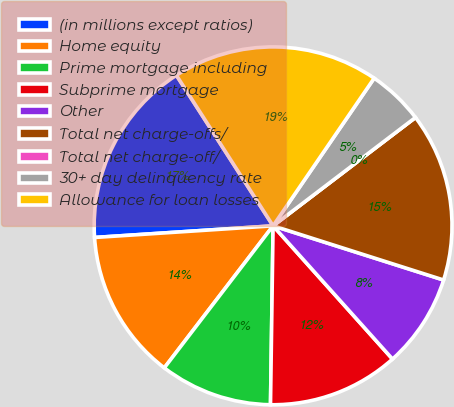<chart> <loc_0><loc_0><loc_500><loc_500><pie_chart><fcel>(in millions except ratios)<fcel>Home equity<fcel>Prime mortgage including<fcel>Subprime mortgage<fcel>Other<fcel>Total net charge-offs/<fcel>Total net charge-off/<fcel>30+ day delinquency rate<fcel>Allowance for loan losses<nl><fcel>16.95%<fcel>13.56%<fcel>10.17%<fcel>11.86%<fcel>8.47%<fcel>15.25%<fcel>0.0%<fcel>5.09%<fcel>18.64%<nl></chart> 